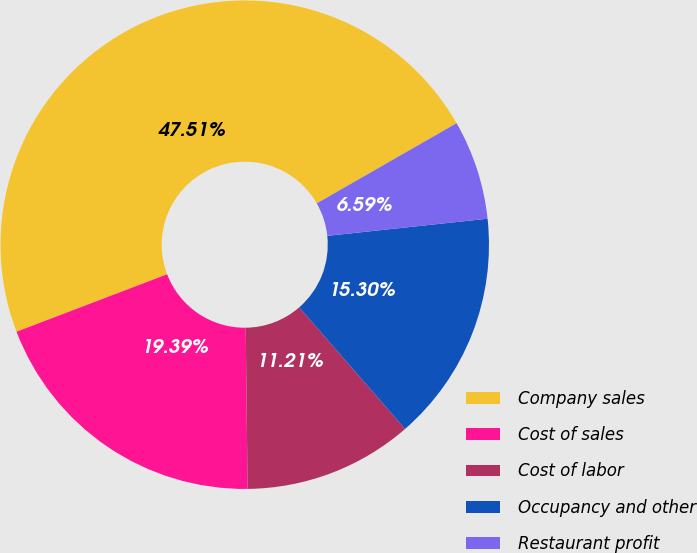<chart> <loc_0><loc_0><loc_500><loc_500><pie_chart><fcel>Company sales<fcel>Cost of sales<fcel>Cost of labor<fcel>Occupancy and other<fcel>Restaurant profit<nl><fcel>47.51%<fcel>19.39%<fcel>11.21%<fcel>15.3%<fcel>6.59%<nl></chart> 